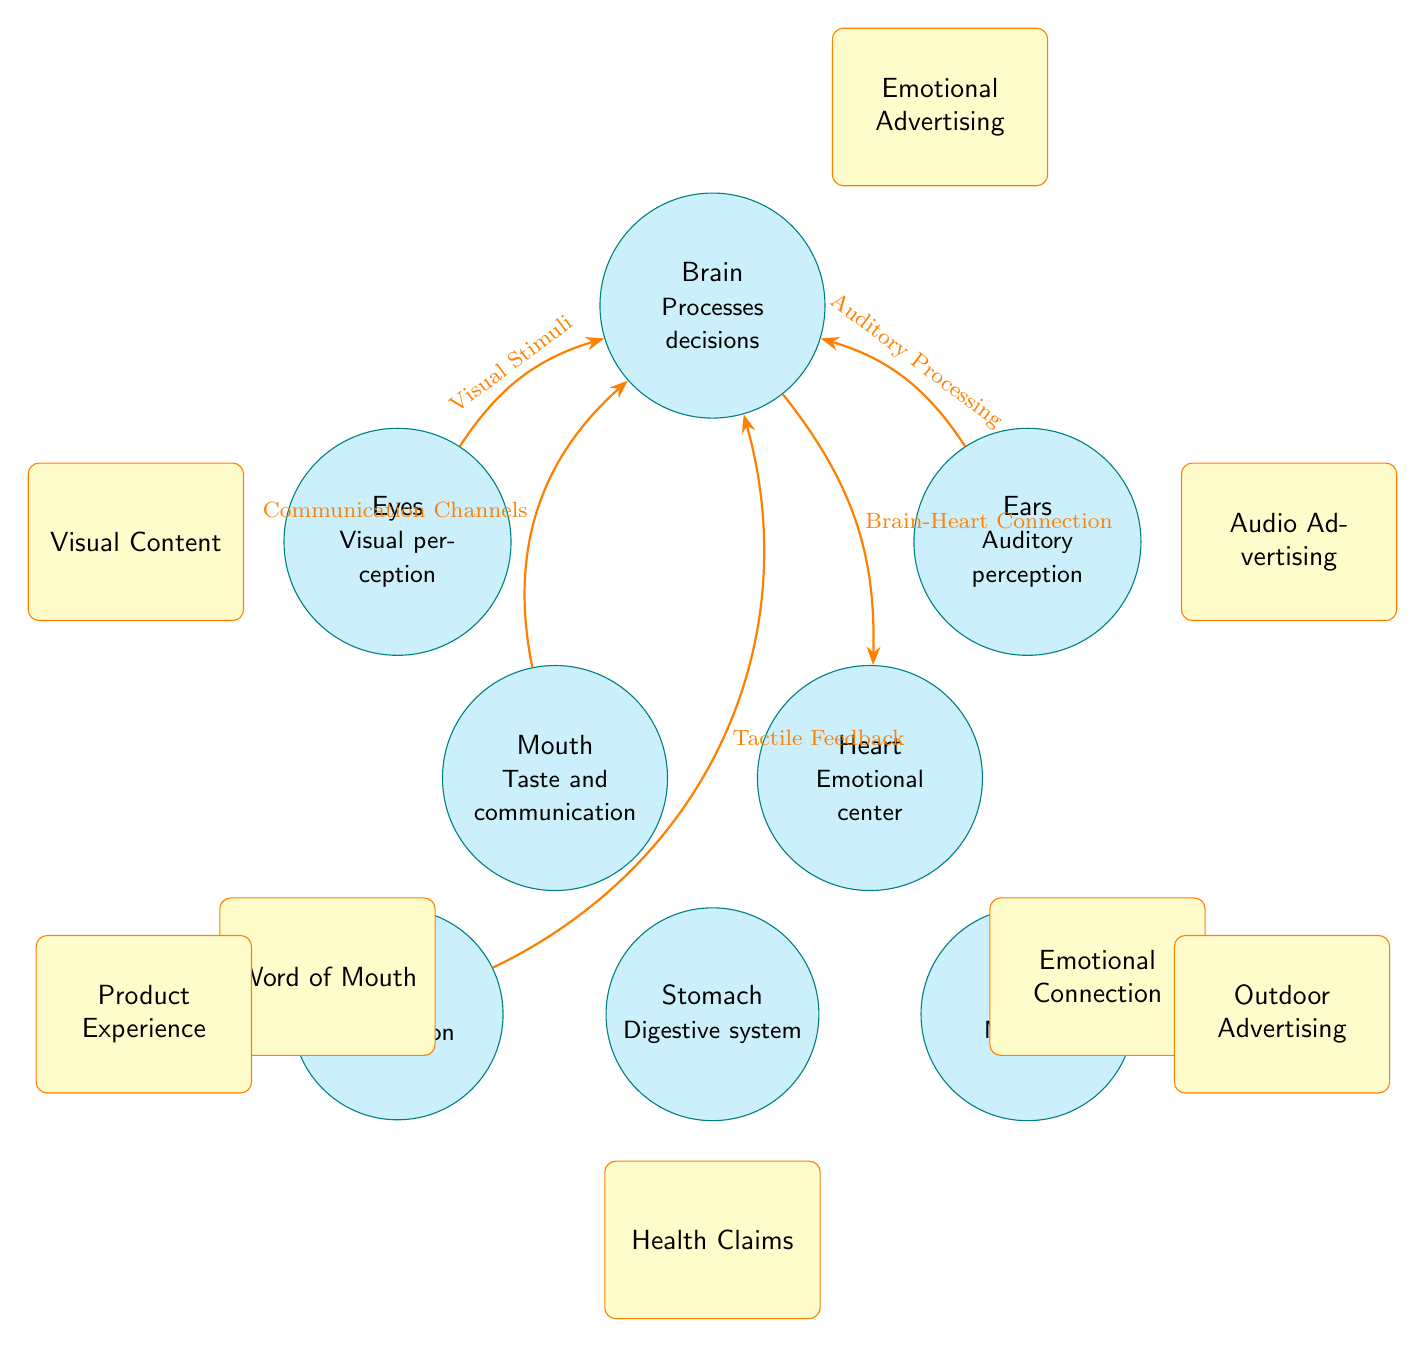What organ is associated with emotional advertising? The "Emotional Advertising" marketing touchpoint is positioned above the "Brain," indicating that it relates to how the brain processes emotions connected to advertisements.
Answer: Brain How many organs are depicted in the diagram? There are eight organs shown in the diagram, which include the brain, eyes, ears, mouth, heart, hands, stomach, and legs.
Answer: 8 What is the connection between the heart and the brain? The connection described between the "Brain" and "Heart" indicates a "Brain-Heart Connection," which implies a relationship where emotional responses influence heart activity.
Answer: Brain-Heart Connection Which marketing touchpoint corresponds to tactile feedback? The marketing touchpoint labeled "Product Experience" is placed to the left of the "Hands," representing the importance of tactile feedback in marketing strategies aimed at consumers.
Answer: Product Experience What sensory input is linked to the brain through the ears? The marketing flow from the "Ears" to the "Brain" is labeled as "Auditory Processing," indicating that auditory stimuli are processed by the brain, aligning with audio marketing strategies.
Answer: Auditory Processing What is the emotional center of the human body according to this diagram? The "Heart" is designated as the "Emotional Center," suggesting that it plays a crucial role in emotional responses, which is vital for emotional marketing strategies.
Answer: Heart How are visual stimuli connected to the brain? Visual stimuli are connected to the brain through the "Eyes," and this relationship is emphasized with the connection line indicating the processing of visual information by the brain.
Answer: Visual Stimuli Which touchpoint is associated with digestive health claims? The marketing touchpoint "Health Claims" is located below the "Stomach," indicating its relevance to digestive health and marketing health products.
Answer: Health Claims What role do hands play in marketing strategies? The connection from "Hands" to "Brain" indicates "Tactile Feedback," highlighting the importance of hands in providing sensory interaction with physical products in marketing.
Answer: Tactile Feedback 